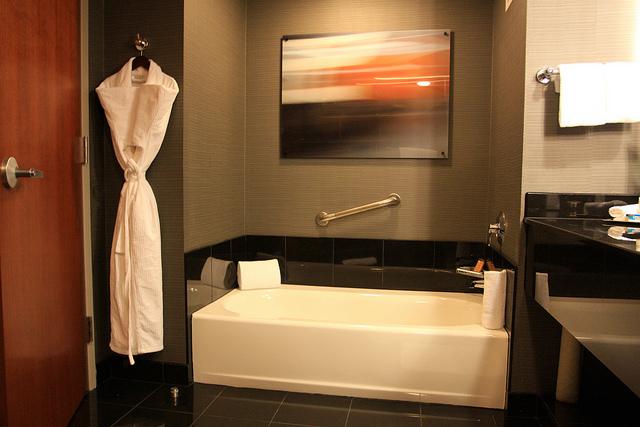Does this look like a hotel bathroom?
Be succinct. Yes. Where is the painting?
Concise answer only. Over bathtub. Is the robe hanging or on the floor?
Concise answer only. Hanging. 